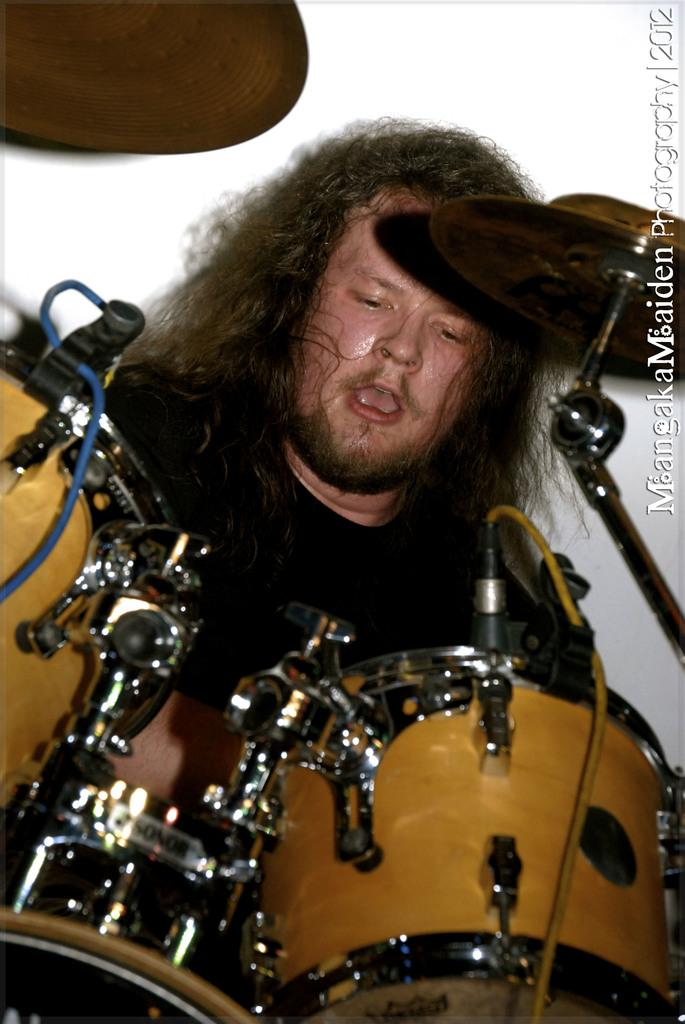What musical instrument is at the bottom of the image? There are drums at the bottom of the image. Who is associated with the drums in the image? A person is sitting behind the drums. What type of teeth can be seen in the image? There are no teeth visible in the image. Is there a stream running through the image? There is no stream present in the image. 